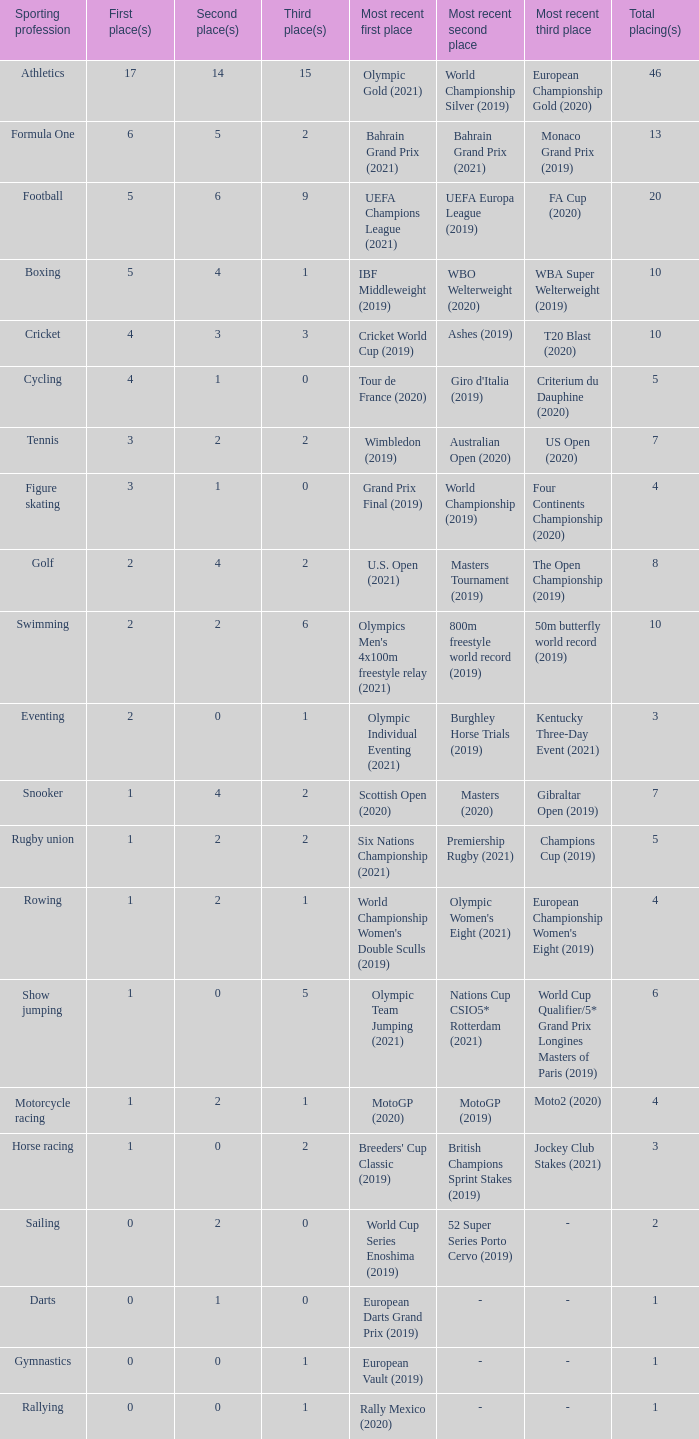How many second place showings does snooker have? 4.0. 